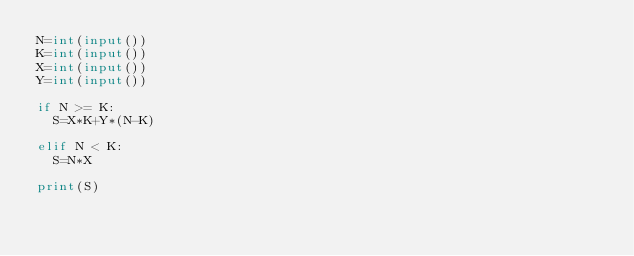Convert code to text. <code><loc_0><loc_0><loc_500><loc_500><_Python_>N=int(input())
K=int(input())
X=int(input())
Y=int(input())

if N >= K:
  S=X*K+Y*(N-K)

elif N < K:
  S=N*X

print(S)</code> 